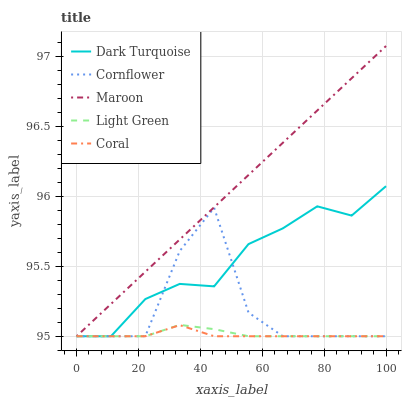Does Coral have the minimum area under the curve?
Answer yes or no. Yes. Does Maroon have the maximum area under the curve?
Answer yes or no. Yes. Does Light Green have the minimum area under the curve?
Answer yes or no. No. Does Light Green have the maximum area under the curve?
Answer yes or no. No. Is Maroon the smoothest?
Answer yes or no. Yes. Is Cornflower the roughest?
Answer yes or no. Yes. Is Coral the smoothest?
Answer yes or no. No. Is Coral the roughest?
Answer yes or no. No. Does Dark Turquoise have the lowest value?
Answer yes or no. Yes. Does Maroon have the highest value?
Answer yes or no. Yes. Does Light Green have the highest value?
Answer yes or no. No. Does Dark Turquoise intersect Maroon?
Answer yes or no. Yes. Is Dark Turquoise less than Maroon?
Answer yes or no. No. Is Dark Turquoise greater than Maroon?
Answer yes or no. No. 